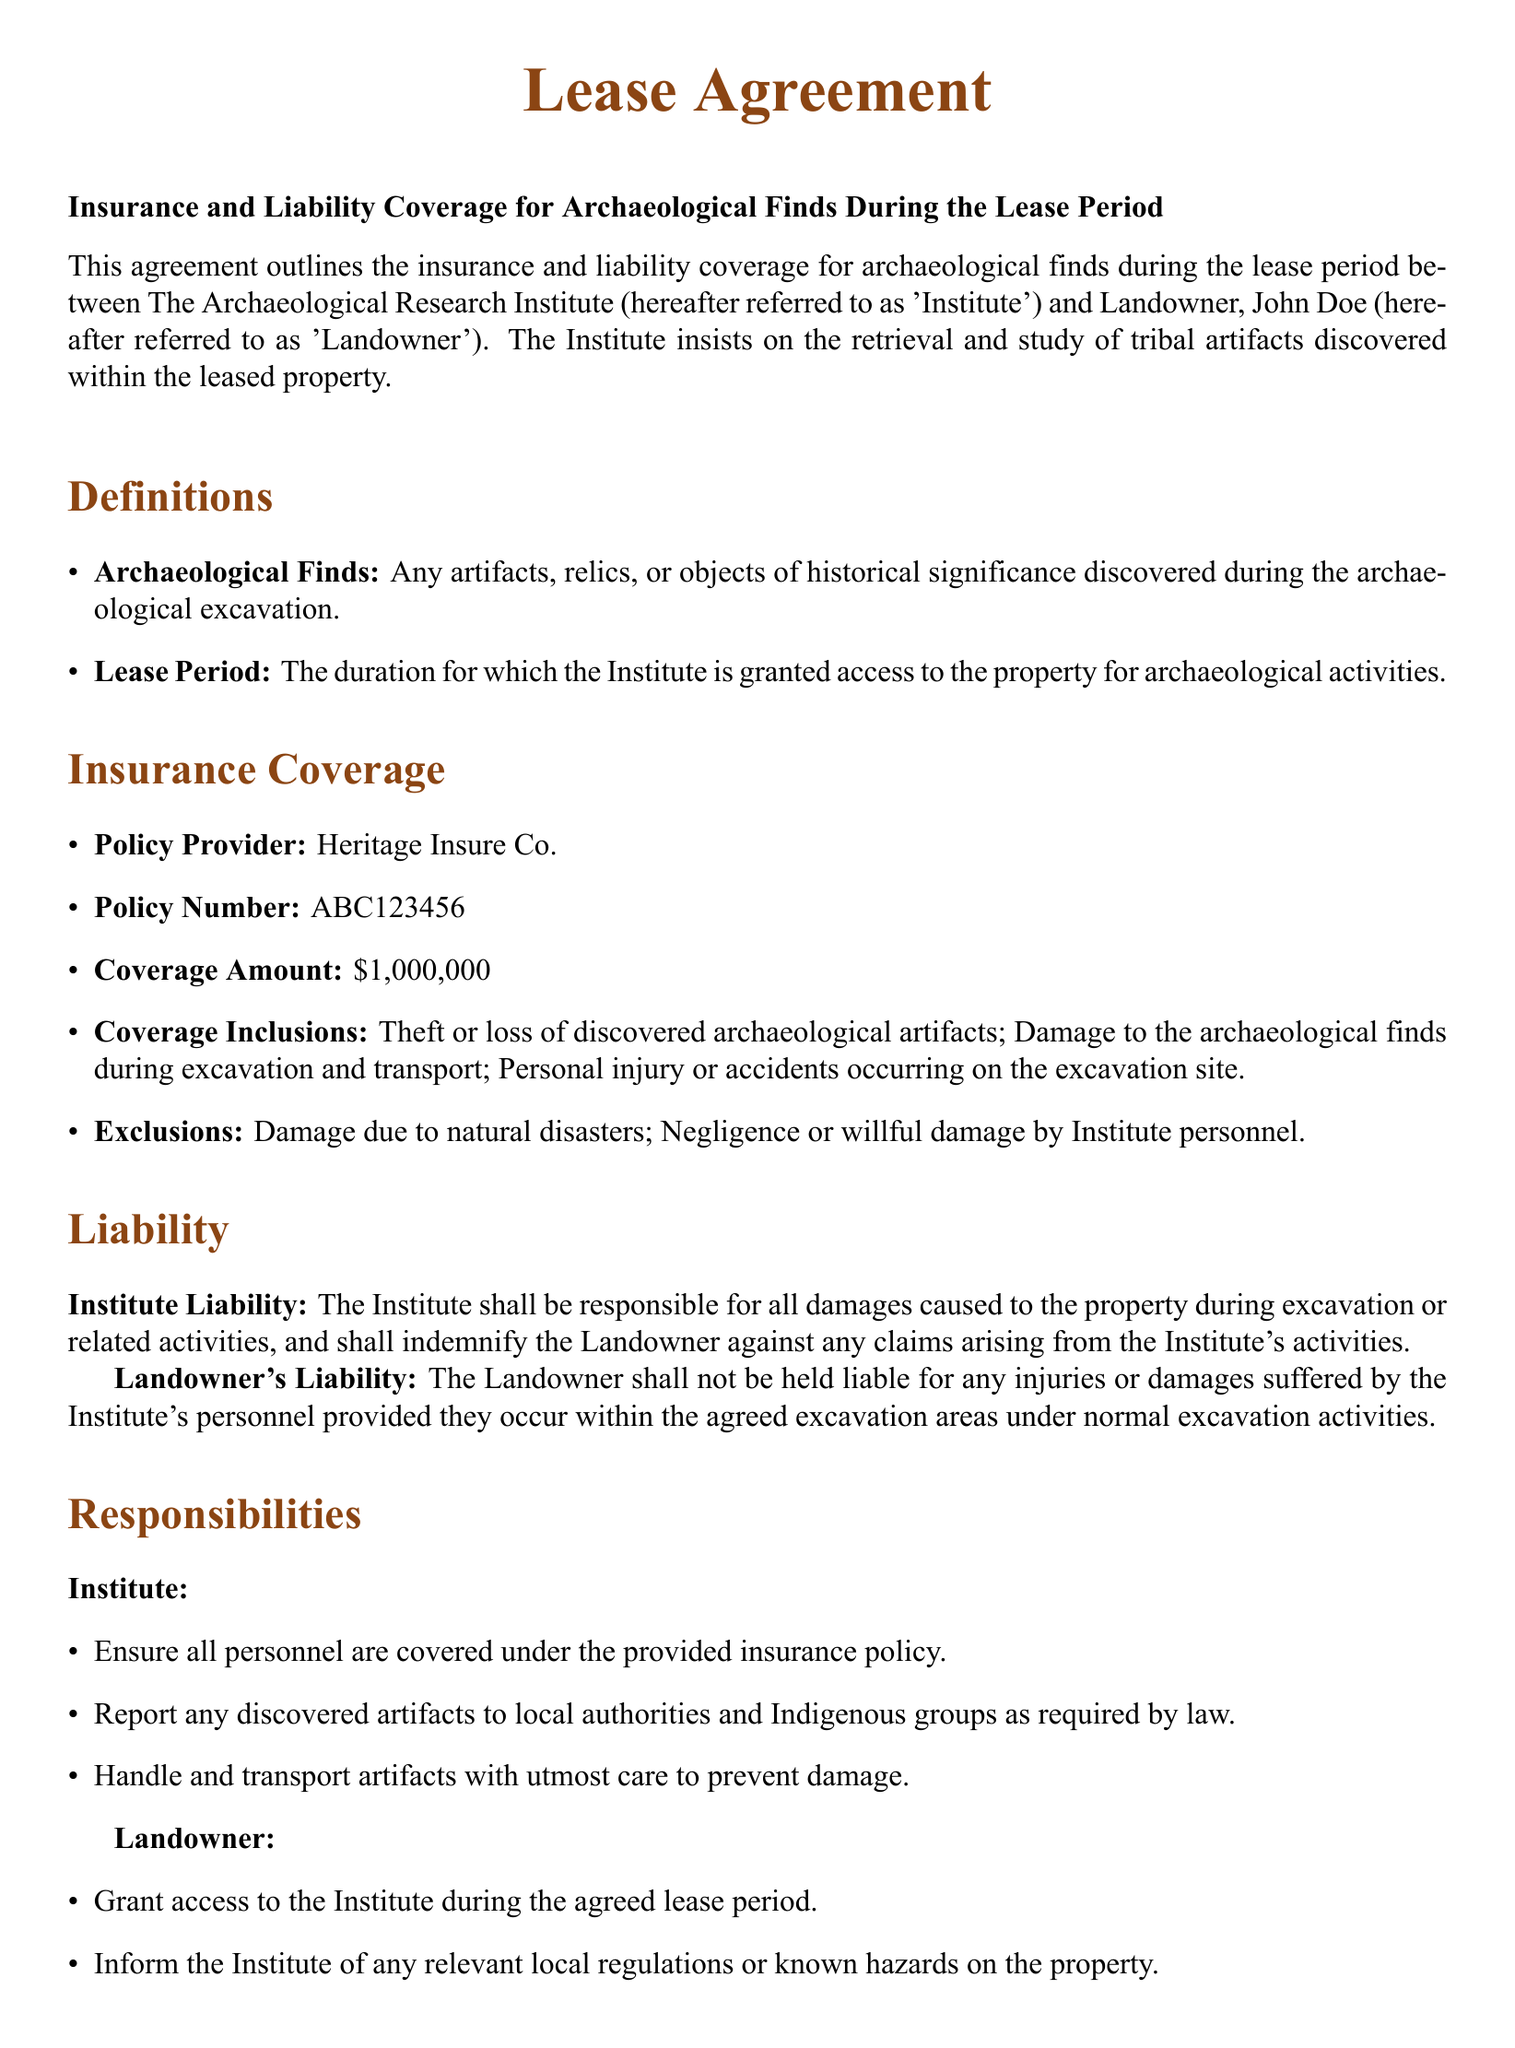What is the policy provider? The document specifies that the insurance policy provider is Heritage Insure Co.
Answer: Heritage Insure Co What is the coverage amount? The agreement states the coverage amount for the insurance is one million dollars.
Answer: $1,000,000 Who is the Landowner? The document identifies the Landowner as John Doe.
Answer: John Doe What are the exclusions in the policy? The exclusions listed in the document are damage due to natural disasters and negligence by Institute personnel.
Answer: Damage due to natural disasters; Negligence or willful damage by Institute personnel What is the date of the agreement? The document shows the date of the agreement is written at the end, indicating when it was signed.
Answer: 10/20/2023 What responsibilities does the Institute have? The document lists several responsibilities for the Institute including ensuring personnel are covered under insurance and handling artifacts with care.
Answer: Ensure all personnel are covered under the provided insurance policy Who is responsible for damages caused during excavation? The document clearly states that the Institute is responsible for all damages caused to the property during excavation or related activities.
Answer: The Institute What is the insurance policy number? The document includes the specific policy number associated with the insurance coverage.
Answer: ABC123456 What must the Landowner inform the Institute about? The document requires the Landowner to inform the Institute of any relevant local regulations or known hazards on the property.
Answer: Relevant local regulations or known hazards 